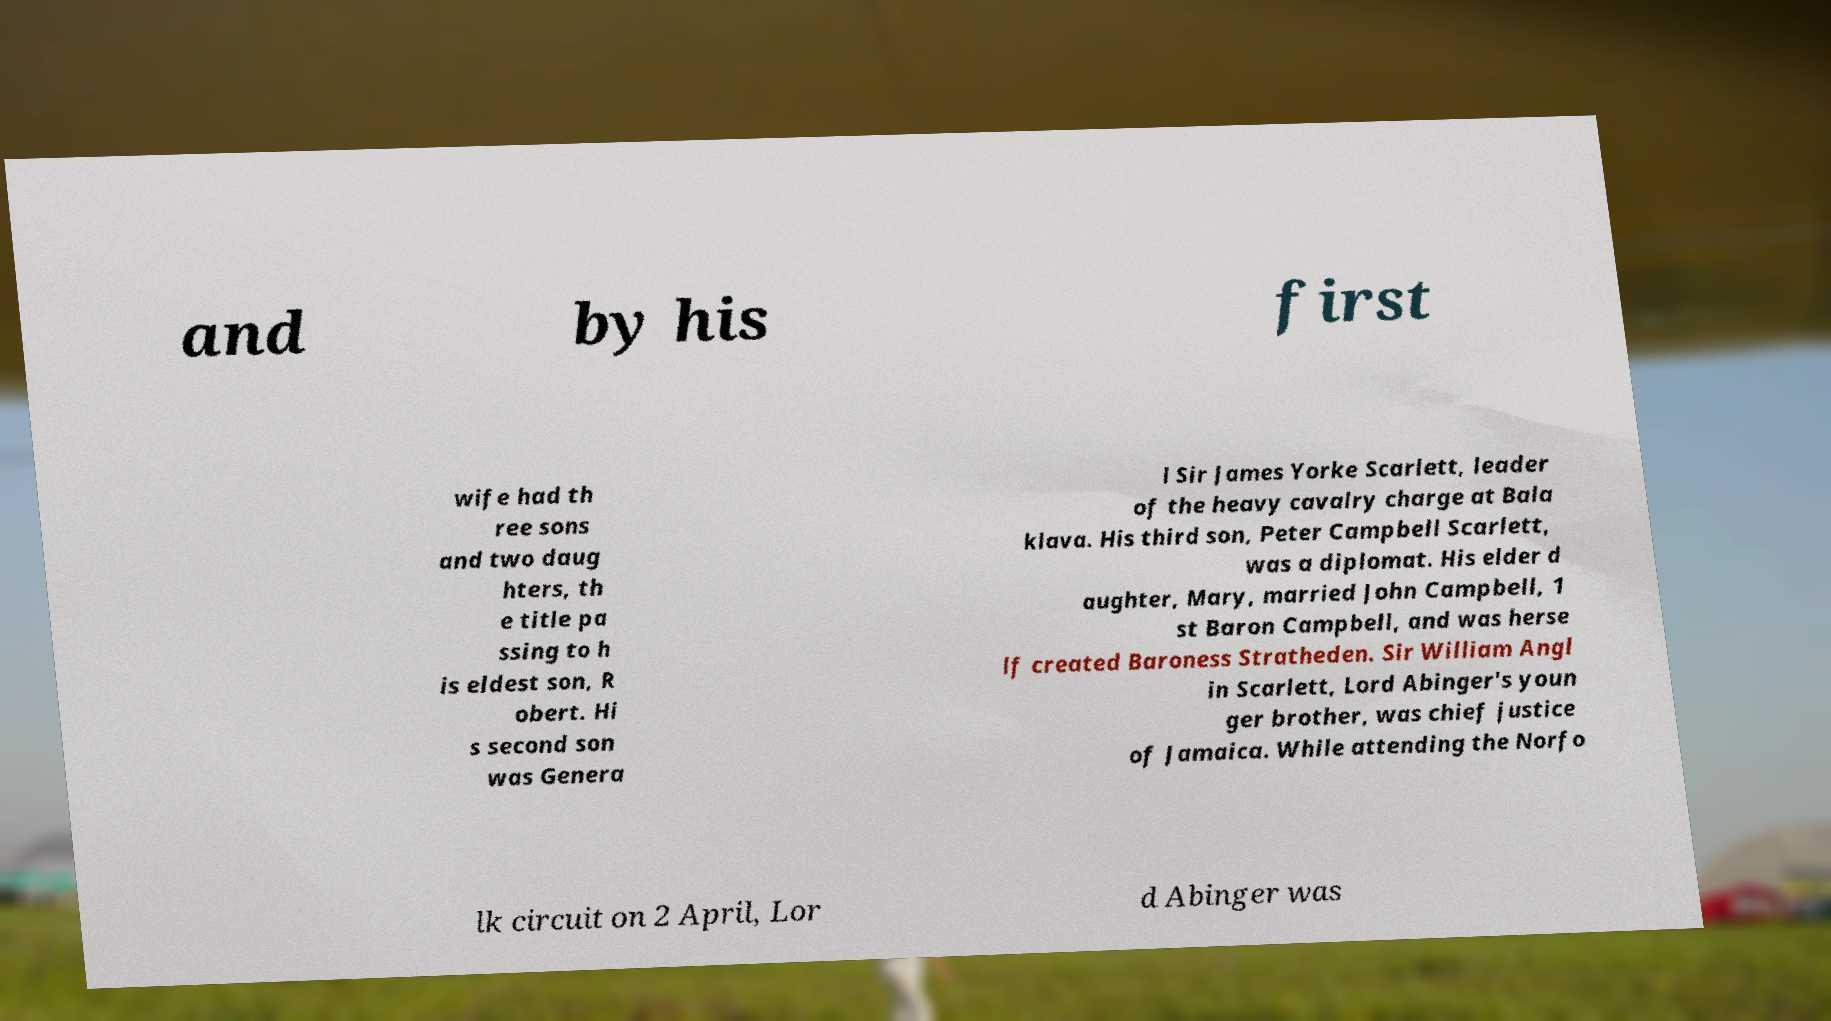Could you assist in decoding the text presented in this image and type it out clearly? and by his first wife had th ree sons and two daug hters, th e title pa ssing to h is eldest son, R obert. Hi s second son was Genera l Sir James Yorke Scarlett, leader of the heavy cavalry charge at Bala klava. His third son, Peter Campbell Scarlett, was a diplomat. His elder d aughter, Mary, married John Campbell, 1 st Baron Campbell, and was herse lf created Baroness Stratheden. Sir William Angl in Scarlett, Lord Abinger's youn ger brother, was chief justice of Jamaica. While attending the Norfo lk circuit on 2 April, Lor d Abinger was 